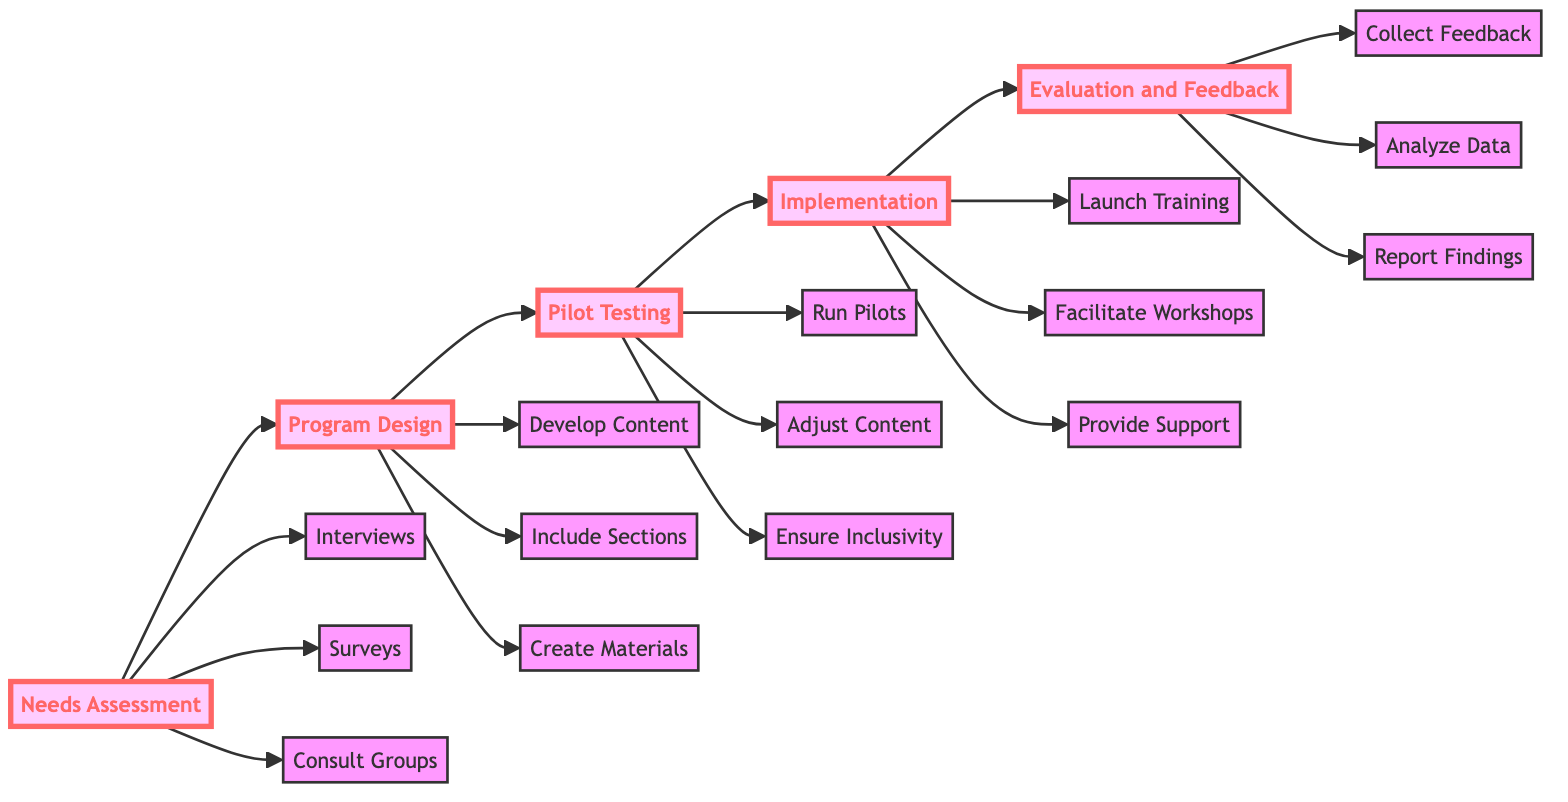What is the first stage in the training program? The diagram starts at the first node labeled "Needs Assessment," indicating this is the first stage in the training program.
Answer: Needs Assessment How many main stages are there in the diagram? The diagram presents a linear flow of five stages from needs assessment through to evaluation and feedback, therefore there are five main stages.
Answer: 5 What activities are included in the "Program Design" stage? The "Program Design" stage branches into three activities: "Develop content with input from LGBTQ+ individuals," "Include sections on the importance of allyship, LGBTQ+ history, and current issues," and "Create engaging materials like interactive videos, personal stories, and real-life case studies."
Answer: Develop content, Include sections, Create engaging materials What happens immediately after "Pilot Testing"? The diagram shows that the flow transitions directly from "Pilot Testing" to "Implementation," indicating that after pilot testing, the next step is implementation.
Answer: Implementation Which stage includes the activity "Collect Feedback"? The activity "Collect Feedback" is part of the "Evaluation and Feedback" stage at the end of the flowchart, which collects feedback to measure the program's effectiveness.
Answer: Evaluation and Feedback How are the activities in the "Needs Assessment" stage categorized? The activities in this stage include conducting interviews, deploying surveys, and consulting advocacy groups; they are specific actions leading to understanding training needs.
Answer: Interviews, Surveys, Consult Groups Which activity emphasizes the need for inclusivity? The "Ensure Inclusivity" activity within the "Pilot Testing" stage emphasizes this aspect, showing the importance of inclusivity in the program.
Answer: Ensure Inclusivity What is the purpose of the "Analysis Data" activity? The "Analyze Data" activity in the "Evaluation and Feedback" stage serves to assess and understand changes in attitudes and behaviors resulting from the training program.
Answer: Analyze Data What is unique about the "Implementation" stage’s activities? The activities in the "Implementation" stage uniquely involve direct interaction with individuals through workshops led by LGBTQ+ storytellers and allies, enhancing the learning experience.
Answer: Facilitate Workshops 